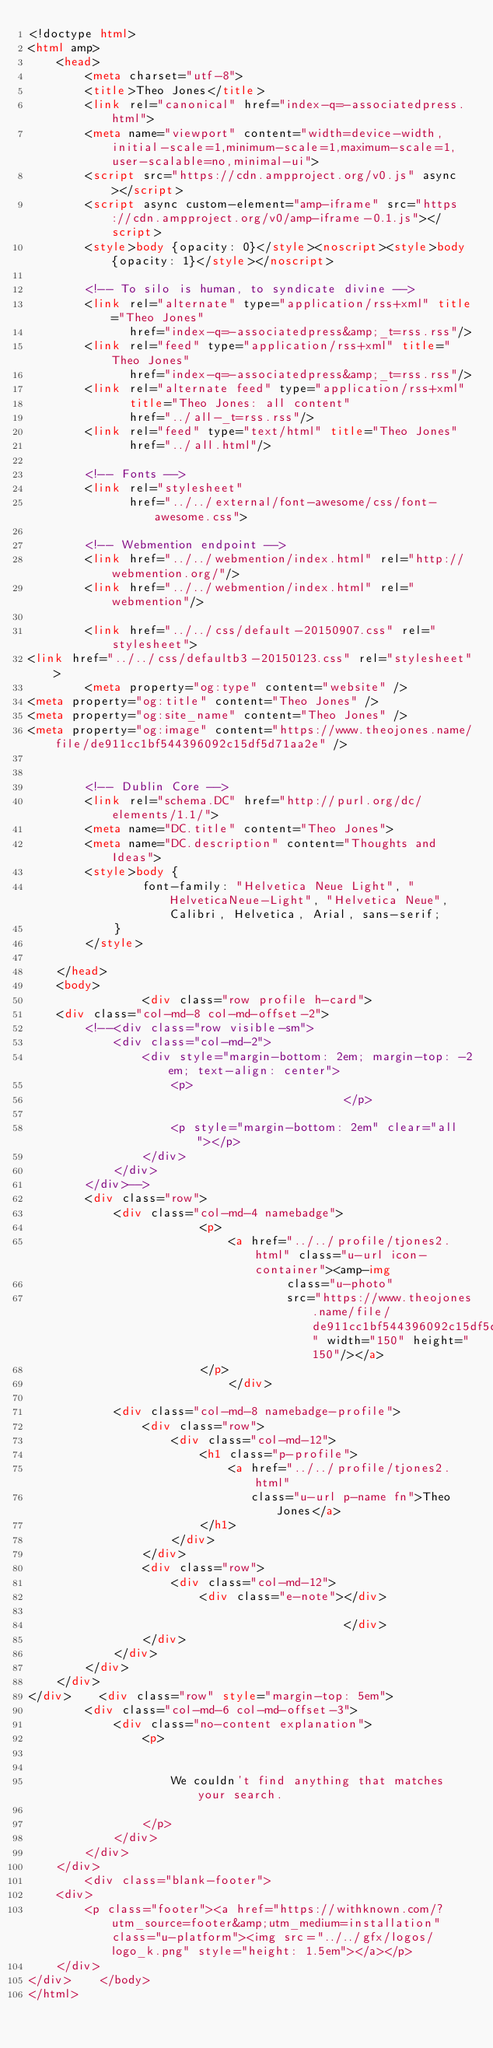Convert code to text. <code><loc_0><loc_0><loc_500><loc_500><_HTML_><!doctype html>
<html amp>
    <head>
        <meta charset="utf-8">
        <title>Theo Jones</title>
        <link rel="canonical" href="index-q=-associatedpress.html">
        <meta name="viewport" content="width=device-width,initial-scale=1,minimum-scale=1,maximum-scale=1,user-scalable=no,minimal-ui">
        <script src="https://cdn.ampproject.org/v0.js" async></script>
        <script async custom-element="amp-iframe" src="https://cdn.ampproject.org/v0/amp-iframe-0.1.js"></script>
        <style>body {opacity: 0}</style><noscript><style>body {opacity: 1}</style></noscript>

        <!-- To silo is human, to syndicate divine -->
        <link rel="alternate" type="application/rss+xml" title="Theo Jones"
              href="index-q=-associatedpress&amp;_t=rss.rss"/>
        <link rel="feed" type="application/rss+xml" title="Theo Jones"
              href="index-q=-associatedpress&amp;_t=rss.rss"/>
        <link rel="alternate feed" type="application/rss+xml"
              title="Theo Jones: all content"
              href="../all-_t=rss.rss"/>
        <link rel="feed" type="text/html" title="Theo Jones"
              href="../all.html"/>

        <!-- Fonts -->
        <link rel="stylesheet"
              href="../../external/font-awesome/css/font-awesome.css">

        <!-- Webmention endpoint -->
        <link href="../../webmention/index.html" rel="http://webmention.org/"/>
        <link href="../../webmention/index.html" rel="webmention"/>

        <link href="../../css/default-20150907.css" rel="stylesheet">
<link href="../../css/defaultb3-20150123.css" rel="stylesheet">
        <meta property="og:type" content="website" />
<meta property="og:title" content="Theo Jones" />
<meta property="og:site_name" content="Theo Jones" />
<meta property="og:image" content="https://www.theojones.name/file/de911cc1bf544396092c15df5d71aa2e" />


        <!-- Dublin Core -->
        <link rel="schema.DC" href="http://purl.org/dc/elements/1.1/">
        <meta name="DC.title" content="Theo Jones">
        <meta name="DC.description" content="Thoughts and Ideas">
        <style>body {
                font-family: "Helvetica Neue Light", "HelveticaNeue-Light", "Helvetica Neue", Calibri, Helvetica, Arial, sans-serif;
            }
        </style>

    </head>
    <body>
                <div class="row profile h-card">
    <div class="col-md-8 col-md-offset-2">
        <!--<div class="row visible-sm">
            <div class="col-md-2">
                <div style="margin-bottom: 2em; margin-top: -2em; text-align: center">
                    <p>
                                            </p>

                    <p style="margin-bottom: 2em" clear="all"></p>
                </div>
            </div>
        </div>-->
        <div class="row">
            <div class="col-md-4 namebadge">
                        <p>
                            <a href="../../profile/tjones2.html" class="u-url icon-container"><amp-img
                                    class="u-photo"
                                    src="https://www.theojones.name/file/de911cc1bf544396092c15df5d71aa2e" width="150" height="150"/></a>
                        </p>
                            </div>

            <div class="col-md-8 namebadge-profile">
                <div class="row">
                    <div class="col-md-12">
                        <h1 class="p-profile">
                            <a href="../../profile/tjones2.html"
                               class="u-url p-name fn">Theo Jones</a>
                        </h1>
                    </div>
                </div>
                <div class="row">
                    <div class="col-md-12">
                        <div class="e-note"></div>

                                            </div>
                </div>
            </div>
        </div>
    </div>
</div>    <div class="row" style="margin-top: 5em">
        <div class="col-md-6 col-md-offset-3">
            <div class="no-content explanation">
                <p>


                    We couldn't find anything that matches your search.

                </p>
            </div>
        </div>
    </div>
        <div class="blank-footer">
    <div>
        <p class="footer"><a href="https://withknown.com/?utm_source=footer&amp;utm_medium=installation" class="u-platform"><img src="../../gfx/logos/logo_k.png" style="height: 1.5em"></a></p>
    </div>
</div>    </body>
</html></code> 